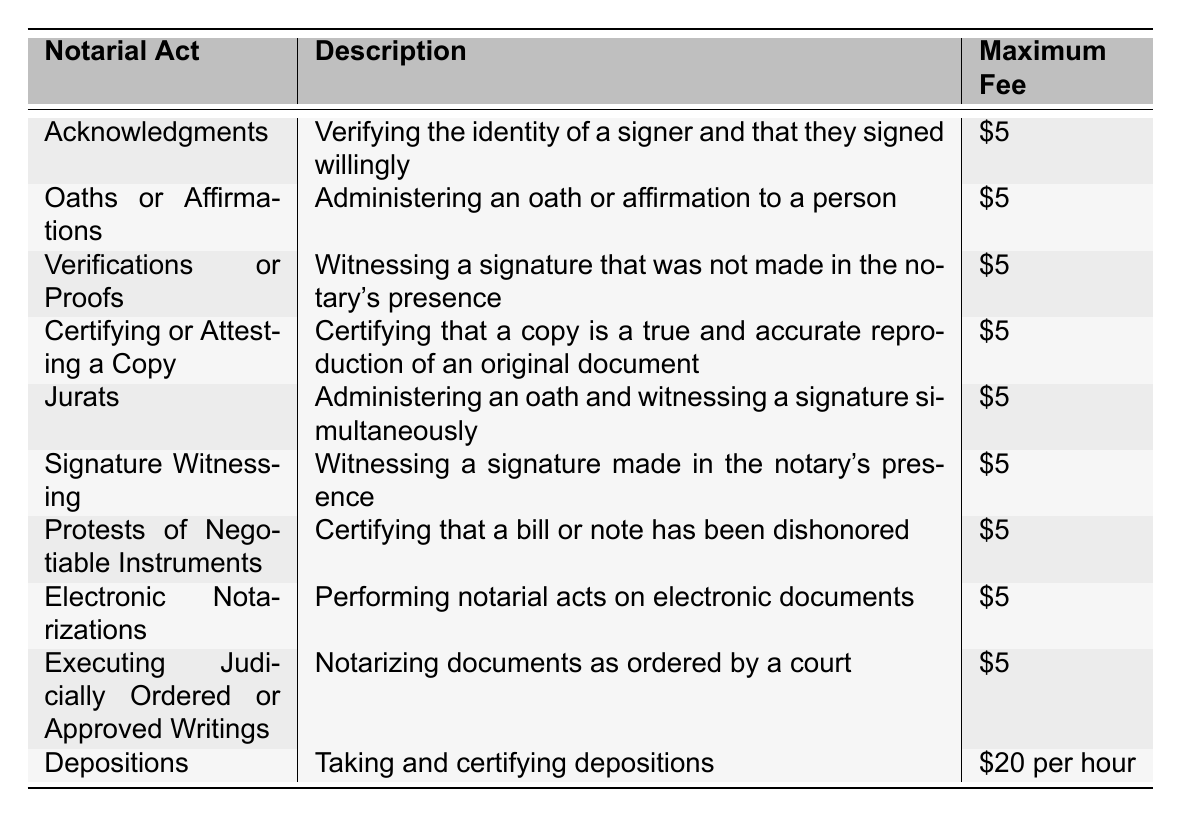What is the maximum fee for Acknowledgments? The table explicitly states that the maximum fee for Acknowledgments is $5.
Answer: $5 What is the fee for Depositions? According to the table, the fee for Depositions is listed as $20 per hour.
Answer: $20 per hour Are Oaths or Affirmations and Acknowledgments the same fee? Yes, both Oaths or Affirmations and Acknowledgments have a maximum fee of $5 as indicated in the table.
Answer: Yes How many notarial acts have a maximum fee of $5? The table lists 9 notarial acts with a maximum fee of $5.
Answer: 9 If you performed an acknowledgment and a jurat, what would be the total fee? The fee for an acknowledgment is $5 and for a jurat is also $5. Therefore, the total fee would be $5 + $5 = $10.
Answer: $10 Is it true that Electronic Notarizations have a different fee compared to other types of acts? No, Electronic Notarizations also have a maximum fee of $5, which is the same as many other types of notarial acts listed.
Answer: No What is the difference in maximum fees between Depositions and the other notarial acts? The maximum fee for Depositions is $20 per hour, while the other acts have a fee of $5, resulting in a difference of $20 - $5 = $15 per act.
Answer: $15 How much would it cost to conduct 3 Acknowledgments? Since each acknowledgment costs $5, the total cost for 3 Acknowledgments would be 3 x $5 = $15.
Answer: $15 What is the maximum fee for a Jurat compared to a Signature Witnessing? Both Jurats and Signature Witnessing have the same maximum fee of $5 according to the table, so there is no difference.
Answer: No difference If someone needed to perform 2 electronic notarizations and 1 deposition, what would be the total charge? The electronic notarizations would total $5 each, which is $10 for 2, and the deposition would cost $20 per hour. Therefore, the total charge would be $10 + $20 = $30.
Answer: $30 